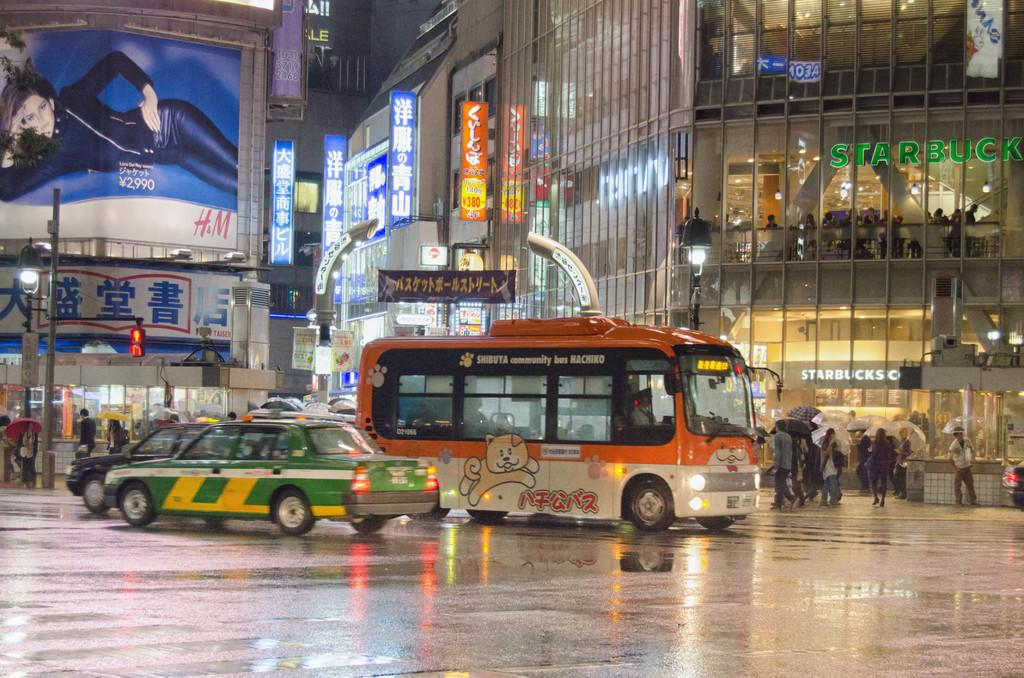Provide a one-sentence caption for the provided image. A green taxi and and orange bus are on a busy street in the rain in front of a large Starbucks. 